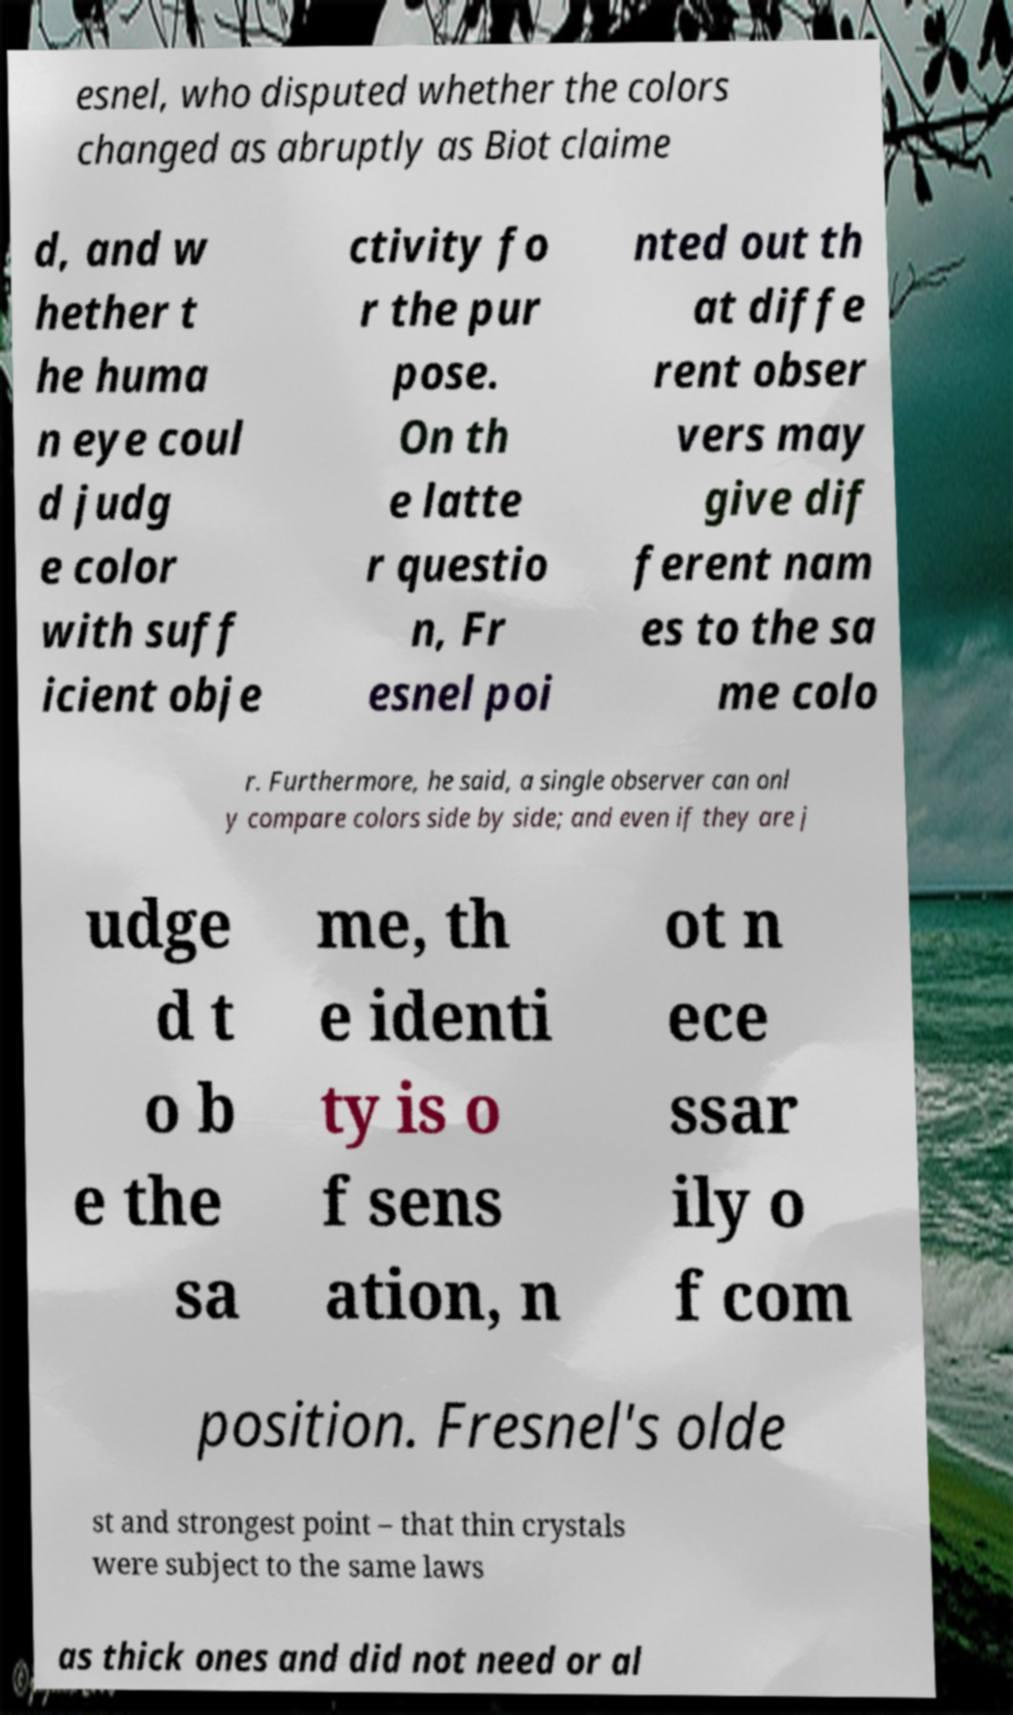Could you extract and type out the text from this image? esnel, who disputed whether the colors changed as abruptly as Biot claime d, and w hether t he huma n eye coul d judg e color with suff icient obje ctivity fo r the pur pose. On th e latte r questio n, Fr esnel poi nted out th at diffe rent obser vers may give dif ferent nam es to the sa me colo r. Furthermore, he said, a single observer can onl y compare colors side by side; and even if they are j udge d t o b e the sa me, th e identi ty is o f sens ation, n ot n ece ssar ily o f com position. Fresnel's olde st and strongest point – that thin crystals were subject to the same laws as thick ones and did not need or al 